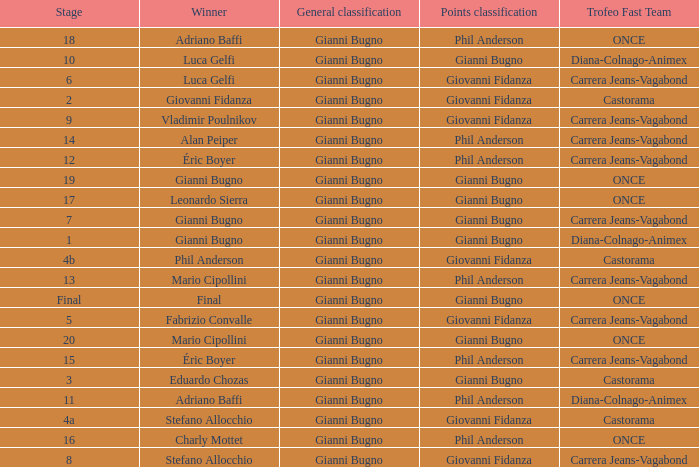What is the stage when the winner is charly mottet? 16.0. 